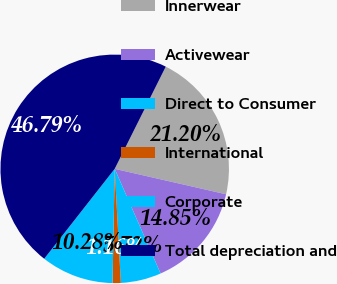<chart> <loc_0><loc_0><loc_500><loc_500><pie_chart><fcel>Innerwear<fcel>Activewear<fcel>Direct to Consumer<fcel>International<fcel>Corporate<fcel>Total depreciation and<nl><fcel>21.2%<fcel>14.85%<fcel>5.72%<fcel>1.16%<fcel>10.28%<fcel>46.79%<nl></chart> 